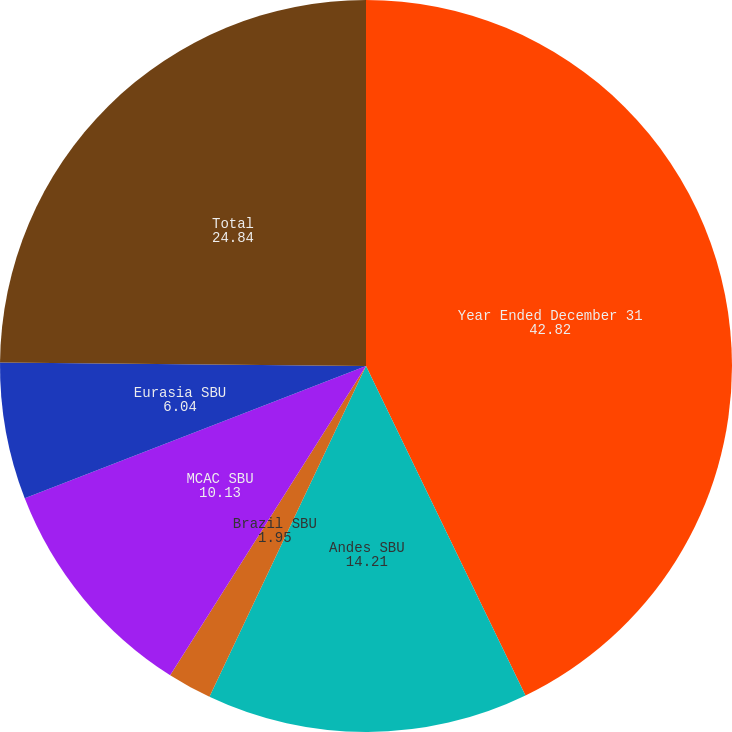<chart> <loc_0><loc_0><loc_500><loc_500><pie_chart><fcel>Year Ended December 31<fcel>Andes SBU<fcel>Brazil SBU<fcel>MCAC SBU<fcel>Eurasia SBU<fcel>Total<nl><fcel>42.82%<fcel>14.21%<fcel>1.95%<fcel>10.13%<fcel>6.04%<fcel>24.84%<nl></chart> 